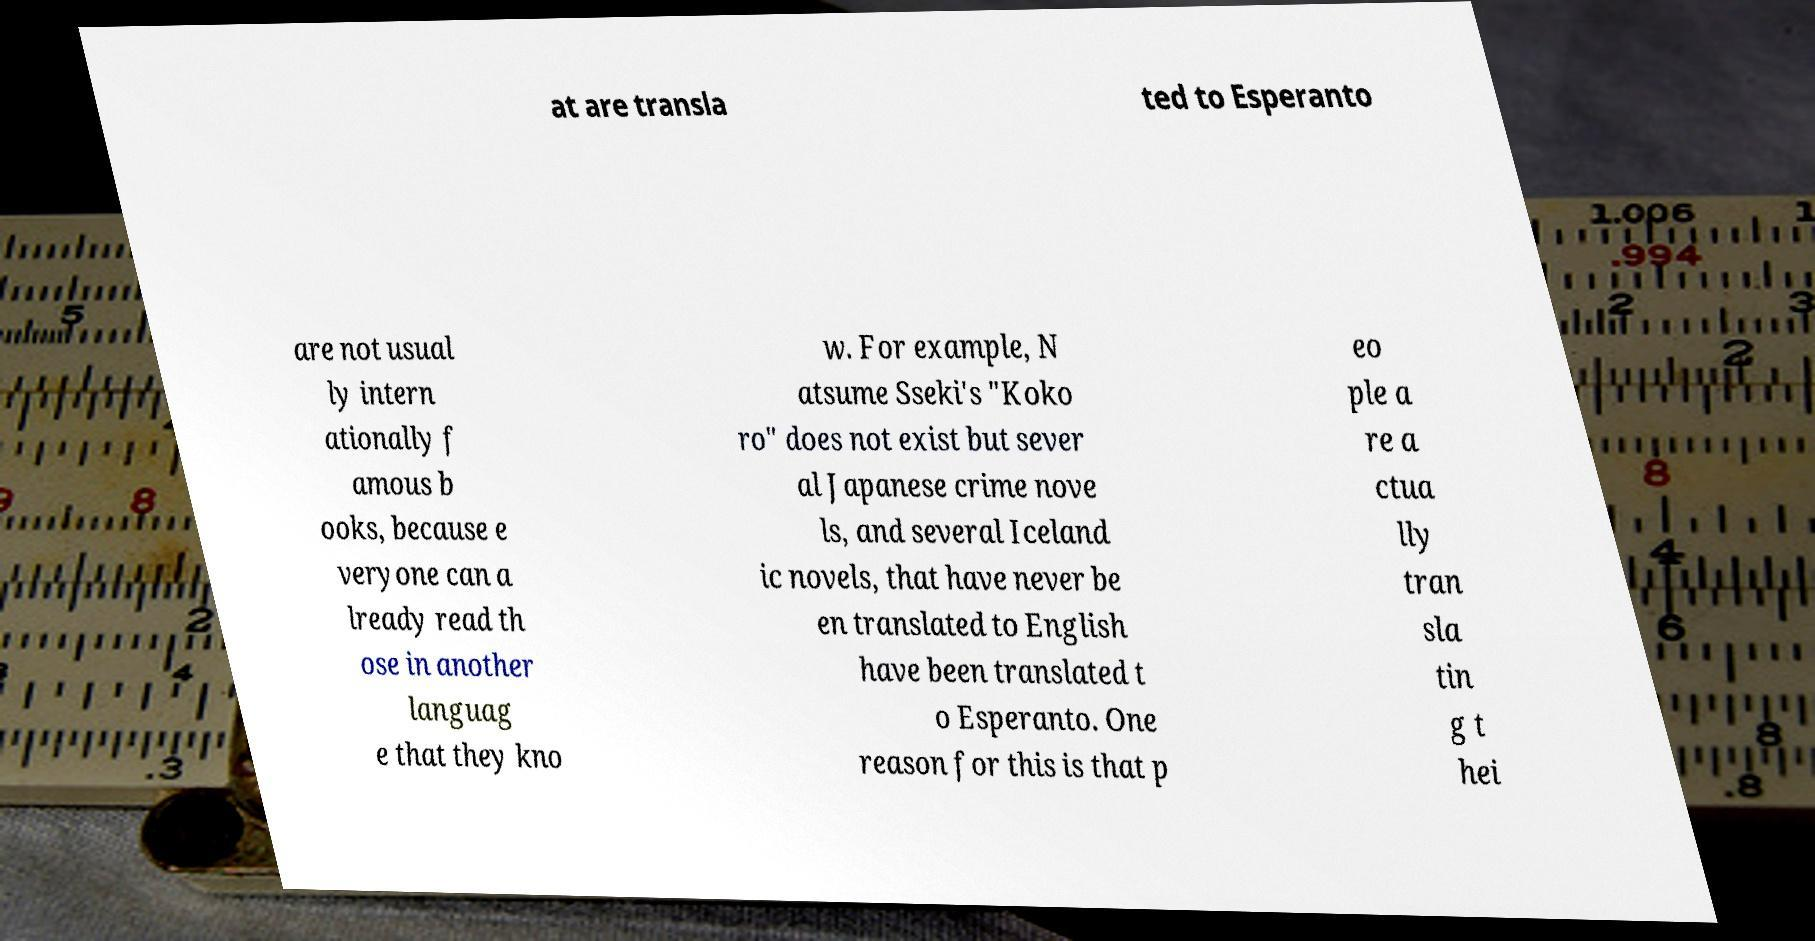Can you accurately transcribe the text from the provided image for me? at are transla ted to Esperanto are not usual ly intern ationally f amous b ooks, because e veryone can a lready read th ose in another languag e that they kno w. For example, N atsume Sseki's "Koko ro" does not exist but sever al Japanese crime nove ls, and several Iceland ic novels, that have never be en translated to English have been translated t o Esperanto. One reason for this is that p eo ple a re a ctua lly tran sla tin g t hei 